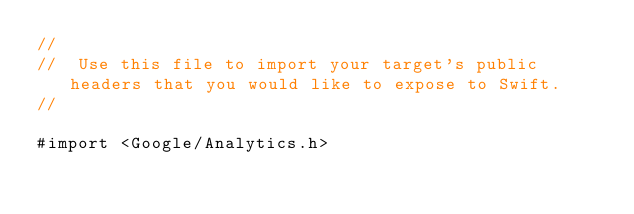Convert code to text. <code><loc_0><loc_0><loc_500><loc_500><_C_>//
//  Use this file to import your target's public headers that you would like to expose to Swift.
//

#import <Google/Analytics.h>
</code> 